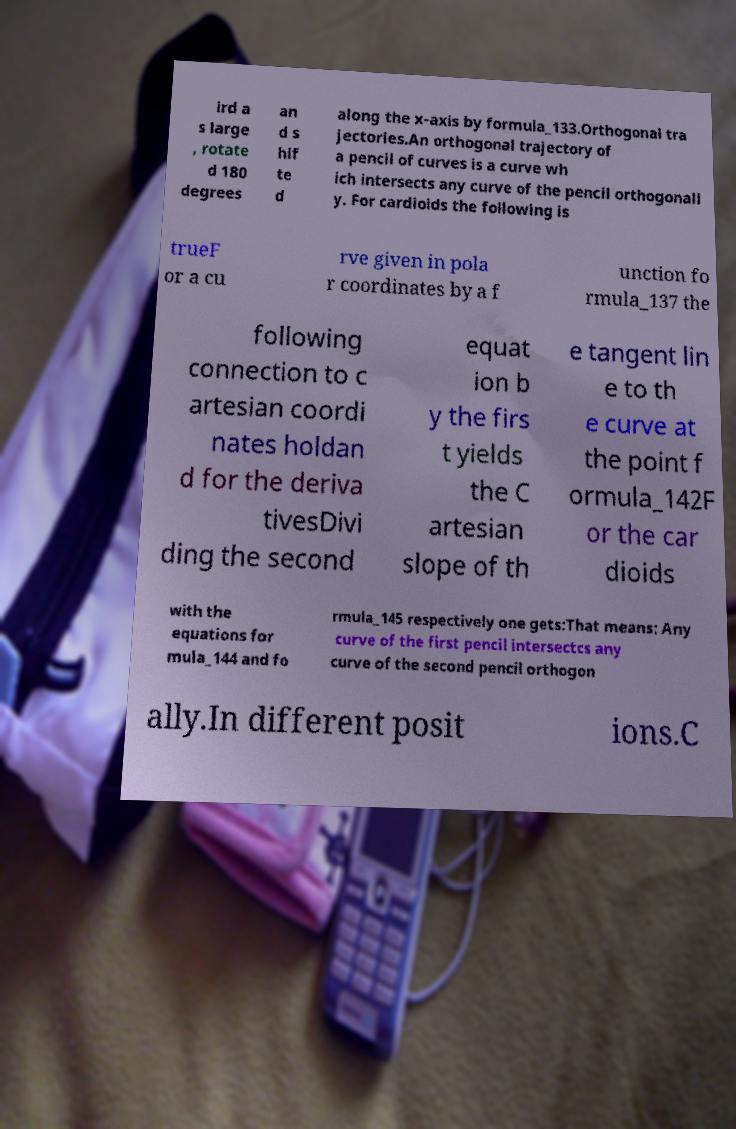What messages or text are displayed in this image? I need them in a readable, typed format. ird a s large , rotate d 180 degrees an d s hif te d along the x-axis by formula_133.Orthogonal tra jectories.An orthogonal trajectory of a pencil of curves is a curve wh ich intersects any curve of the pencil orthogonall y. For cardioids the following is trueF or a cu rve given in pola r coordinates by a f unction fo rmula_137 the following connection to c artesian coordi nates holdan d for the deriva tivesDivi ding the second equat ion b y the firs t yields the C artesian slope of th e tangent lin e to th e curve at the point f ormula_142F or the car dioids with the equations for mula_144 and fo rmula_145 respectively one gets:That means: Any curve of the first pencil intersectcs any curve of the second pencil orthogon ally.In different posit ions.C 